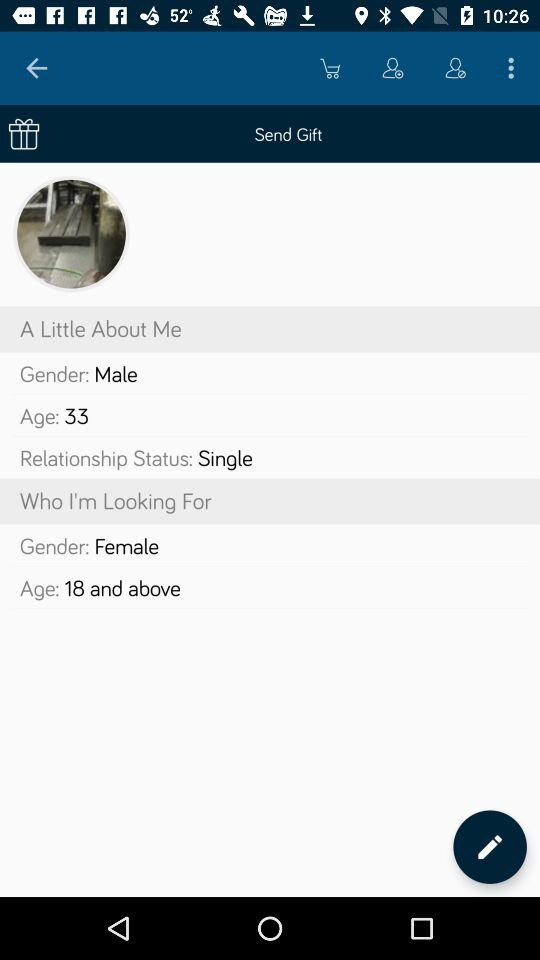What is the gender? The genders are male and female. 